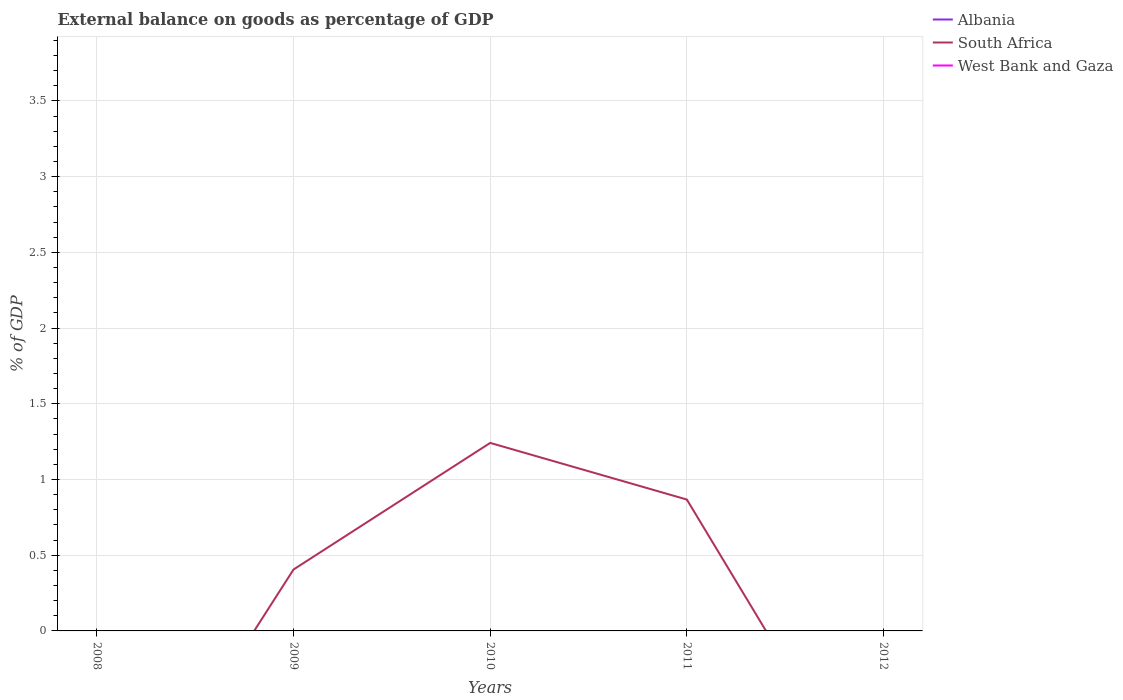Is the number of lines equal to the number of legend labels?
Keep it short and to the point. No. Across all years, what is the maximum external balance on goods as percentage of GDP in South Africa?
Offer a terse response. 0. What is the difference between the highest and the second highest external balance on goods as percentage of GDP in South Africa?
Provide a succinct answer. 1.24. What is the difference between the highest and the lowest external balance on goods as percentage of GDP in West Bank and Gaza?
Provide a short and direct response. 0. Is the external balance on goods as percentage of GDP in Albania strictly greater than the external balance on goods as percentage of GDP in West Bank and Gaza over the years?
Give a very brief answer. No. How many years are there in the graph?
Give a very brief answer. 5. Are the values on the major ticks of Y-axis written in scientific E-notation?
Offer a very short reply. No. Does the graph contain grids?
Your answer should be compact. Yes. Where does the legend appear in the graph?
Provide a short and direct response. Top right. What is the title of the graph?
Your answer should be compact. External balance on goods as percentage of GDP. Does "China" appear as one of the legend labels in the graph?
Offer a very short reply. No. What is the label or title of the X-axis?
Provide a succinct answer. Years. What is the label or title of the Y-axis?
Offer a terse response. % of GDP. What is the % of GDP of South Africa in 2009?
Provide a succinct answer. 0.41. What is the % of GDP of South Africa in 2010?
Give a very brief answer. 1.24. What is the % of GDP of West Bank and Gaza in 2010?
Offer a terse response. 0. What is the % of GDP of South Africa in 2011?
Make the answer very short. 0.87. What is the % of GDP of West Bank and Gaza in 2011?
Offer a very short reply. 0. What is the % of GDP in Albania in 2012?
Provide a succinct answer. 0. Across all years, what is the maximum % of GDP in South Africa?
Make the answer very short. 1.24. What is the total % of GDP of Albania in the graph?
Provide a short and direct response. 0. What is the total % of GDP in South Africa in the graph?
Your response must be concise. 2.51. What is the total % of GDP in West Bank and Gaza in the graph?
Provide a succinct answer. 0. What is the difference between the % of GDP of South Africa in 2009 and that in 2010?
Your response must be concise. -0.84. What is the difference between the % of GDP of South Africa in 2009 and that in 2011?
Keep it short and to the point. -0.46. What is the difference between the % of GDP of South Africa in 2010 and that in 2011?
Your answer should be compact. 0.37. What is the average % of GDP of South Africa per year?
Your answer should be compact. 0.5. What is the average % of GDP in West Bank and Gaza per year?
Keep it short and to the point. 0. What is the ratio of the % of GDP in South Africa in 2009 to that in 2010?
Keep it short and to the point. 0.33. What is the ratio of the % of GDP in South Africa in 2009 to that in 2011?
Your response must be concise. 0.47. What is the ratio of the % of GDP in South Africa in 2010 to that in 2011?
Offer a very short reply. 1.43. What is the difference between the highest and the second highest % of GDP in South Africa?
Ensure brevity in your answer.  0.37. What is the difference between the highest and the lowest % of GDP of South Africa?
Your response must be concise. 1.24. 